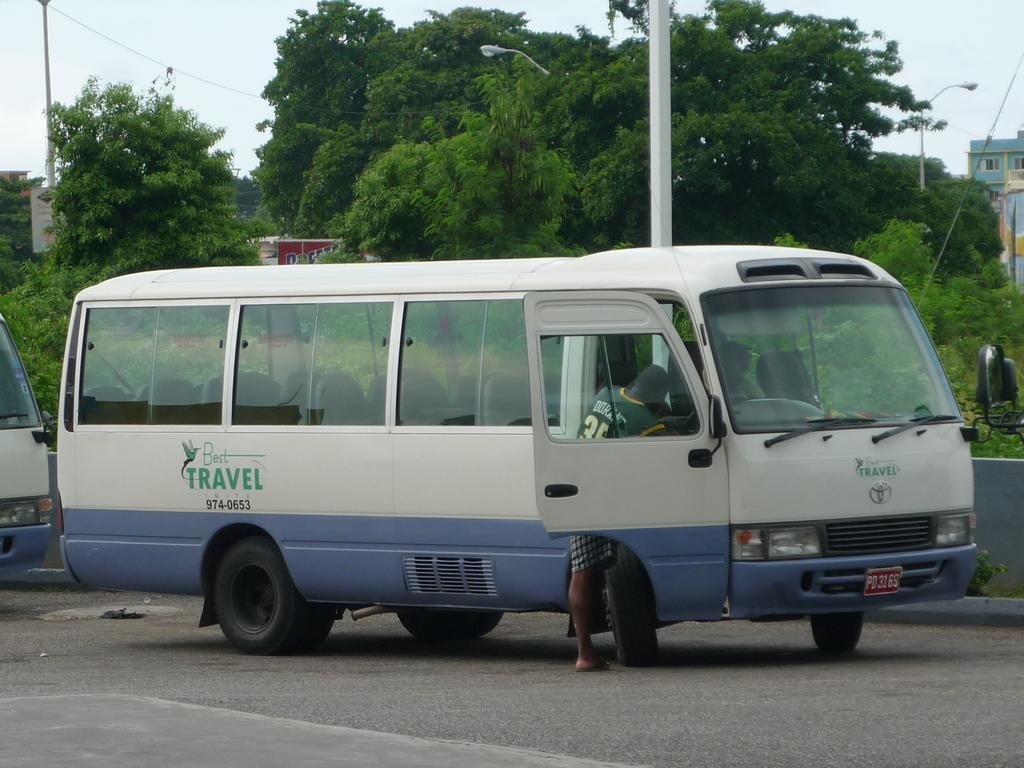<image>
Offer a succinct explanation of the picture presented. A white and blue shuttle bus for Best Travel. 